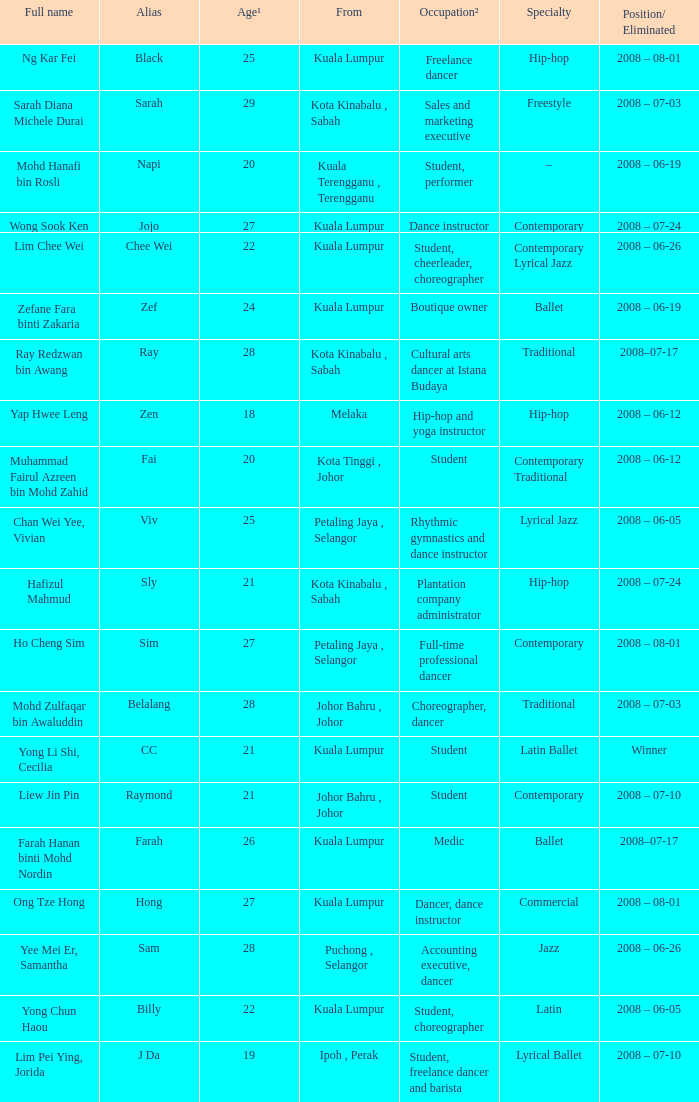What is Full Name, when Age¹ is "20", and when Occupation² is "Student"? Muhammad Fairul Azreen bin Mohd Zahid. 